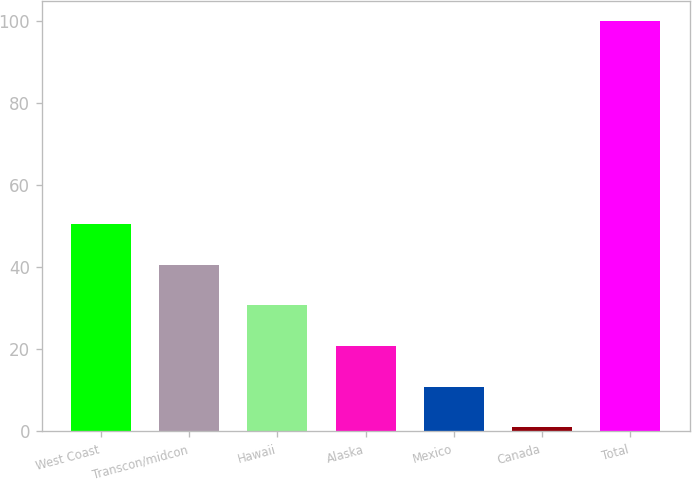Convert chart. <chart><loc_0><loc_0><loc_500><loc_500><bar_chart><fcel>West Coast<fcel>Transcon/midcon<fcel>Hawaii<fcel>Alaska<fcel>Mexico<fcel>Canada<fcel>Total<nl><fcel>50.5<fcel>40.6<fcel>30.7<fcel>20.8<fcel>10.9<fcel>1<fcel>100<nl></chart> 